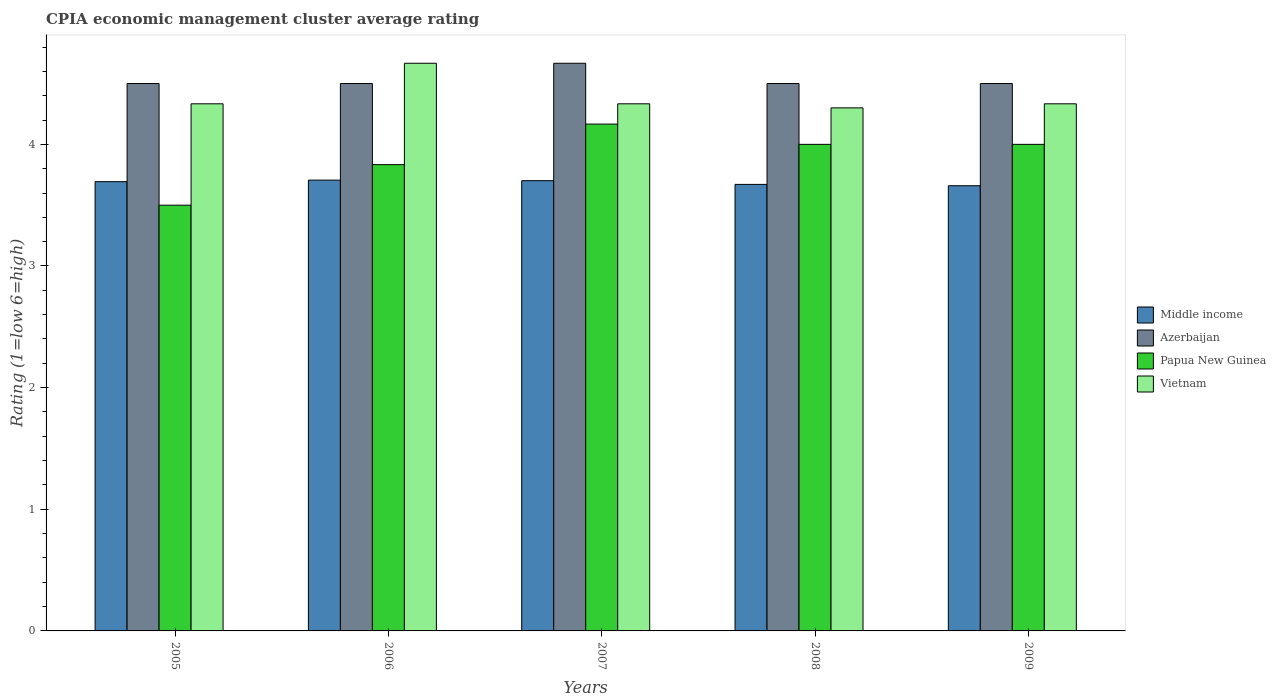Are the number of bars per tick equal to the number of legend labels?
Make the answer very short. Yes. How many bars are there on the 3rd tick from the left?
Make the answer very short. 4. What is the label of the 2nd group of bars from the left?
Your response must be concise. 2006. In how many cases, is the number of bars for a given year not equal to the number of legend labels?
Provide a succinct answer. 0. What is the CPIA rating in Middle income in 2008?
Your answer should be compact. 3.67. Across all years, what is the maximum CPIA rating in Azerbaijan?
Ensure brevity in your answer.  4.67. Across all years, what is the minimum CPIA rating in Middle income?
Keep it short and to the point. 3.66. In which year was the CPIA rating in Vietnam minimum?
Provide a succinct answer. 2008. What is the total CPIA rating in Vietnam in the graph?
Your answer should be compact. 21.97. What is the difference between the CPIA rating in Middle income in 2006 and that in 2008?
Provide a succinct answer. 0.04. What is the difference between the CPIA rating in Middle income in 2009 and the CPIA rating in Azerbaijan in 2006?
Provide a short and direct response. -0.84. In the year 2009, what is the difference between the CPIA rating in Middle income and CPIA rating in Papua New Guinea?
Your answer should be very brief. -0.34. In how many years, is the CPIA rating in Middle income greater than 3.6?
Provide a short and direct response. 5. What is the ratio of the CPIA rating in Azerbaijan in 2007 to that in 2008?
Your answer should be compact. 1.04. Is the CPIA rating in Middle income in 2007 less than that in 2009?
Provide a succinct answer. No. What is the difference between the highest and the second highest CPIA rating in Vietnam?
Your answer should be compact. 0.33. What is the difference between the highest and the lowest CPIA rating in Papua New Guinea?
Make the answer very short. 0.67. Is it the case that in every year, the sum of the CPIA rating in Papua New Guinea and CPIA rating in Azerbaijan is greater than the sum of CPIA rating in Vietnam and CPIA rating in Middle income?
Your answer should be compact. No. What does the 3rd bar from the left in 2009 represents?
Make the answer very short. Papua New Guinea. What does the 2nd bar from the right in 2007 represents?
Provide a short and direct response. Papua New Guinea. How many bars are there?
Provide a succinct answer. 20. Are all the bars in the graph horizontal?
Ensure brevity in your answer.  No. How many years are there in the graph?
Your response must be concise. 5. Does the graph contain grids?
Provide a short and direct response. No. Where does the legend appear in the graph?
Make the answer very short. Center right. What is the title of the graph?
Provide a succinct answer. CPIA economic management cluster average rating. What is the Rating (1=low 6=high) in Middle income in 2005?
Your response must be concise. 3.69. What is the Rating (1=low 6=high) in Azerbaijan in 2005?
Offer a terse response. 4.5. What is the Rating (1=low 6=high) of Papua New Guinea in 2005?
Provide a succinct answer. 3.5. What is the Rating (1=low 6=high) in Vietnam in 2005?
Ensure brevity in your answer.  4.33. What is the Rating (1=low 6=high) of Middle income in 2006?
Your response must be concise. 3.71. What is the Rating (1=low 6=high) in Azerbaijan in 2006?
Provide a short and direct response. 4.5. What is the Rating (1=low 6=high) of Papua New Guinea in 2006?
Provide a succinct answer. 3.83. What is the Rating (1=low 6=high) in Vietnam in 2006?
Your answer should be very brief. 4.67. What is the Rating (1=low 6=high) of Middle income in 2007?
Ensure brevity in your answer.  3.7. What is the Rating (1=low 6=high) in Azerbaijan in 2007?
Provide a short and direct response. 4.67. What is the Rating (1=low 6=high) in Papua New Guinea in 2007?
Your answer should be compact. 4.17. What is the Rating (1=low 6=high) of Vietnam in 2007?
Provide a short and direct response. 4.33. What is the Rating (1=low 6=high) of Middle income in 2008?
Your response must be concise. 3.67. What is the Rating (1=low 6=high) in Azerbaijan in 2008?
Offer a terse response. 4.5. What is the Rating (1=low 6=high) in Papua New Guinea in 2008?
Ensure brevity in your answer.  4. What is the Rating (1=low 6=high) in Vietnam in 2008?
Your answer should be compact. 4.3. What is the Rating (1=low 6=high) in Middle income in 2009?
Your answer should be very brief. 3.66. What is the Rating (1=low 6=high) in Vietnam in 2009?
Ensure brevity in your answer.  4.33. Across all years, what is the maximum Rating (1=low 6=high) in Middle income?
Give a very brief answer. 3.71. Across all years, what is the maximum Rating (1=low 6=high) of Azerbaijan?
Ensure brevity in your answer.  4.67. Across all years, what is the maximum Rating (1=low 6=high) in Papua New Guinea?
Provide a short and direct response. 4.17. Across all years, what is the maximum Rating (1=low 6=high) of Vietnam?
Keep it short and to the point. 4.67. Across all years, what is the minimum Rating (1=low 6=high) in Middle income?
Ensure brevity in your answer.  3.66. Across all years, what is the minimum Rating (1=low 6=high) of Azerbaijan?
Offer a terse response. 4.5. Across all years, what is the minimum Rating (1=low 6=high) in Vietnam?
Give a very brief answer. 4.3. What is the total Rating (1=low 6=high) in Middle income in the graph?
Keep it short and to the point. 18.43. What is the total Rating (1=low 6=high) of Azerbaijan in the graph?
Offer a terse response. 22.67. What is the total Rating (1=low 6=high) in Vietnam in the graph?
Offer a terse response. 21.97. What is the difference between the Rating (1=low 6=high) of Middle income in 2005 and that in 2006?
Offer a terse response. -0.01. What is the difference between the Rating (1=low 6=high) in Azerbaijan in 2005 and that in 2006?
Give a very brief answer. 0. What is the difference between the Rating (1=low 6=high) of Papua New Guinea in 2005 and that in 2006?
Your response must be concise. -0.33. What is the difference between the Rating (1=low 6=high) in Middle income in 2005 and that in 2007?
Provide a short and direct response. -0.01. What is the difference between the Rating (1=low 6=high) of Papua New Guinea in 2005 and that in 2007?
Keep it short and to the point. -0.67. What is the difference between the Rating (1=low 6=high) in Vietnam in 2005 and that in 2007?
Make the answer very short. 0. What is the difference between the Rating (1=low 6=high) in Middle income in 2005 and that in 2008?
Your response must be concise. 0.02. What is the difference between the Rating (1=low 6=high) of Azerbaijan in 2005 and that in 2008?
Give a very brief answer. 0. What is the difference between the Rating (1=low 6=high) in Papua New Guinea in 2005 and that in 2008?
Your response must be concise. -0.5. What is the difference between the Rating (1=low 6=high) of Middle income in 2005 and that in 2009?
Provide a succinct answer. 0.03. What is the difference between the Rating (1=low 6=high) of Azerbaijan in 2005 and that in 2009?
Keep it short and to the point. 0. What is the difference between the Rating (1=low 6=high) of Papua New Guinea in 2005 and that in 2009?
Ensure brevity in your answer.  -0.5. What is the difference between the Rating (1=low 6=high) of Vietnam in 2005 and that in 2009?
Provide a succinct answer. 0. What is the difference between the Rating (1=low 6=high) in Middle income in 2006 and that in 2007?
Offer a very short reply. 0. What is the difference between the Rating (1=low 6=high) of Azerbaijan in 2006 and that in 2007?
Ensure brevity in your answer.  -0.17. What is the difference between the Rating (1=low 6=high) in Papua New Guinea in 2006 and that in 2007?
Offer a terse response. -0.33. What is the difference between the Rating (1=low 6=high) in Vietnam in 2006 and that in 2007?
Make the answer very short. 0.33. What is the difference between the Rating (1=low 6=high) of Middle income in 2006 and that in 2008?
Offer a very short reply. 0.04. What is the difference between the Rating (1=low 6=high) of Azerbaijan in 2006 and that in 2008?
Provide a succinct answer. 0. What is the difference between the Rating (1=low 6=high) of Papua New Guinea in 2006 and that in 2008?
Ensure brevity in your answer.  -0.17. What is the difference between the Rating (1=low 6=high) in Vietnam in 2006 and that in 2008?
Offer a terse response. 0.37. What is the difference between the Rating (1=low 6=high) of Middle income in 2006 and that in 2009?
Make the answer very short. 0.05. What is the difference between the Rating (1=low 6=high) of Papua New Guinea in 2006 and that in 2009?
Your response must be concise. -0.17. What is the difference between the Rating (1=low 6=high) of Vietnam in 2006 and that in 2009?
Give a very brief answer. 0.33. What is the difference between the Rating (1=low 6=high) in Middle income in 2007 and that in 2008?
Your answer should be very brief. 0.03. What is the difference between the Rating (1=low 6=high) in Azerbaijan in 2007 and that in 2008?
Your answer should be compact. 0.17. What is the difference between the Rating (1=low 6=high) in Papua New Guinea in 2007 and that in 2008?
Ensure brevity in your answer.  0.17. What is the difference between the Rating (1=low 6=high) of Middle income in 2007 and that in 2009?
Provide a short and direct response. 0.04. What is the difference between the Rating (1=low 6=high) in Azerbaijan in 2007 and that in 2009?
Offer a terse response. 0.17. What is the difference between the Rating (1=low 6=high) in Middle income in 2008 and that in 2009?
Keep it short and to the point. 0.01. What is the difference between the Rating (1=low 6=high) of Azerbaijan in 2008 and that in 2009?
Keep it short and to the point. 0. What is the difference between the Rating (1=low 6=high) of Vietnam in 2008 and that in 2009?
Offer a very short reply. -0.03. What is the difference between the Rating (1=low 6=high) in Middle income in 2005 and the Rating (1=low 6=high) in Azerbaijan in 2006?
Provide a short and direct response. -0.81. What is the difference between the Rating (1=low 6=high) of Middle income in 2005 and the Rating (1=low 6=high) of Papua New Guinea in 2006?
Keep it short and to the point. -0.14. What is the difference between the Rating (1=low 6=high) of Middle income in 2005 and the Rating (1=low 6=high) of Vietnam in 2006?
Your response must be concise. -0.97. What is the difference between the Rating (1=low 6=high) of Papua New Guinea in 2005 and the Rating (1=low 6=high) of Vietnam in 2006?
Provide a short and direct response. -1.17. What is the difference between the Rating (1=low 6=high) in Middle income in 2005 and the Rating (1=low 6=high) in Azerbaijan in 2007?
Give a very brief answer. -0.97. What is the difference between the Rating (1=low 6=high) of Middle income in 2005 and the Rating (1=low 6=high) of Papua New Guinea in 2007?
Provide a short and direct response. -0.47. What is the difference between the Rating (1=low 6=high) of Middle income in 2005 and the Rating (1=low 6=high) of Vietnam in 2007?
Offer a terse response. -0.64. What is the difference between the Rating (1=low 6=high) in Azerbaijan in 2005 and the Rating (1=low 6=high) in Vietnam in 2007?
Offer a terse response. 0.17. What is the difference between the Rating (1=low 6=high) in Papua New Guinea in 2005 and the Rating (1=low 6=high) in Vietnam in 2007?
Give a very brief answer. -0.83. What is the difference between the Rating (1=low 6=high) of Middle income in 2005 and the Rating (1=low 6=high) of Azerbaijan in 2008?
Ensure brevity in your answer.  -0.81. What is the difference between the Rating (1=low 6=high) in Middle income in 2005 and the Rating (1=low 6=high) in Papua New Guinea in 2008?
Ensure brevity in your answer.  -0.31. What is the difference between the Rating (1=low 6=high) in Middle income in 2005 and the Rating (1=low 6=high) in Vietnam in 2008?
Your answer should be very brief. -0.61. What is the difference between the Rating (1=low 6=high) in Azerbaijan in 2005 and the Rating (1=low 6=high) in Vietnam in 2008?
Keep it short and to the point. 0.2. What is the difference between the Rating (1=low 6=high) of Papua New Guinea in 2005 and the Rating (1=low 6=high) of Vietnam in 2008?
Your answer should be compact. -0.8. What is the difference between the Rating (1=low 6=high) of Middle income in 2005 and the Rating (1=low 6=high) of Azerbaijan in 2009?
Keep it short and to the point. -0.81. What is the difference between the Rating (1=low 6=high) of Middle income in 2005 and the Rating (1=low 6=high) of Papua New Guinea in 2009?
Your answer should be compact. -0.31. What is the difference between the Rating (1=low 6=high) of Middle income in 2005 and the Rating (1=low 6=high) of Vietnam in 2009?
Your response must be concise. -0.64. What is the difference between the Rating (1=low 6=high) in Azerbaijan in 2005 and the Rating (1=low 6=high) in Papua New Guinea in 2009?
Provide a short and direct response. 0.5. What is the difference between the Rating (1=low 6=high) of Azerbaijan in 2005 and the Rating (1=low 6=high) of Vietnam in 2009?
Provide a short and direct response. 0.17. What is the difference between the Rating (1=low 6=high) in Papua New Guinea in 2005 and the Rating (1=low 6=high) in Vietnam in 2009?
Provide a succinct answer. -0.83. What is the difference between the Rating (1=low 6=high) of Middle income in 2006 and the Rating (1=low 6=high) of Azerbaijan in 2007?
Offer a very short reply. -0.96. What is the difference between the Rating (1=low 6=high) in Middle income in 2006 and the Rating (1=low 6=high) in Papua New Guinea in 2007?
Keep it short and to the point. -0.46. What is the difference between the Rating (1=low 6=high) of Middle income in 2006 and the Rating (1=low 6=high) of Vietnam in 2007?
Offer a very short reply. -0.63. What is the difference between the Rating (1=low 6=high) of Azerbaijan in 2006 and the Rating (1=low 6=high) of Papua New Guinea in 2007?
Your answer should be compact. 0.33. What is the difference between the Rating (1=low 6=high) in Papua New Guinea in 2006 and the Rating (1=low 6=high) in Vietnam in 2007?
Ensure brevity in your answer.  -0.5. What is the difference between the Rating (1=low 6=high) in Middle income in 2006 and the Rating (1=low 6=high) in Azerbaijan in 2008?
Provide a succinct answer. -0.79. What is the difference between the Rating (1=low 6=high) of Middle income in 2006 and the Rating (1=low 6=high) of Papua New Guinea in 2008?
Keep it short and to the point. -0.29. What is the difference between the Rating (1=low 6=high) in Middle income in 2006 and the Rating (1=low 6=high) in Vietnam in 2008?
Provide a short and direct response. -0.59. What is the difference between the Rating (1=low 6=high) in Azerbaijan in 2006 and the Rating (1=low 6=high) in Vietnam in 2008?
Your answer should be very brief. 0.2. What is the difference between the Rating (1=low 6=high) of Papua New Guinea in 2006 and the Rating (1=low 6=high) of Vietnam in 2008?
Make the answer very short. -0.47. What is the difference between the Rating (1=low 6=high) of Middle income in 2006 and the Rating (1=low 6=high) of Azerbaijan in 2009?
Your response must be concise. -0.79. What is the difference between the Rating (1=low 6=high) of Middle income in 2006 and the Rating (1=low 6=high) of Papua New Guinea in 2009?
Make the answer very short. -0.29. What is the difference between the Rating (1=low 6=high) in Middle income in 2006 and the Rating (1=low 6=high) in Vietnam in 2009?
Your answer should be compact. -0.63. What is the difference between the Rating (1=low 6=high) of Azerbaijan in 2006 and the Rating (1=low 6=high) of Papua New Guinea in 2009?
Your response must be concise. 0.5. What is the difference between the Rating (1=low 6=high) in Middle income in 2007 and the Rating (1=low 6=high) in Azerbaijan in 2008?
Provide a short and direct response. -0.8. What is the difference between the Rating (1=low 6=high) in Middle income in 2007 and the Rating (1=low 6=high) in Papua New Guinea in 2008?
Your response must be concise. -0.3. What is the difference between the Rating (1=low 6=high) in Middle income in 2007 and the Rating (1=low 6=high) in Vietnam in 2008?
Offer a terse response. -0.6. What is the difference between the Rating (1=low 6=high) of Azerbaijan in 2007 and the Rating (1=low 6=high) of Vietnam in 2008?
Provide a succinct answer. 0.37. What is the difference between the Rating (1=low 6=high) in Papua New Guinea in 2007 and the Rating (1=low 6=high) in Vietnam in 2008?
Your answer should be very brief. -0.13. What is the difference between the Rating (1=low 6=high) in Middle income in 2007 and the Rating (1=low 6=high) in Azerbaijan in 2009?
Keep it short and to the point. -0.8. What is the difference between the Rating (1=low 6=high) in Middle income in 2007 and the Rating (1=low 6=high) in Papua New Guinea in 2009?
Offer a terse response. -0.3. What is the difference between the Rating (1=low 6=high) in Middle income in 2007 and the Rating (1=low 6=high) in Vietnam in 2009?
Provide a short and direct response. -0.63. What is the difference between the Rating (1=low 6=high) of Middle income in 2008 and the Rating (1=low 6=high) of Azerbaijan in 2009?
Provide a short and direct response. -0.83. What is the difference between the Rating (1=low 6=high) of Middle income in 2008 and the Rating (1=low 6=high) of Papua New Guinea in 2009?
Give a very brief answer. -0.33. What is the difference between the Rating (1=low 6=high) in Middle income in 2008 and the Rating (1=low 6=high) in Vietnam in 2009?
Make the answer very short. -0.66. What is the difference between the Rating (1=low 6=high) of Azerbaijan in 2008 and the Rating (1=low 6=high) of Vietnam in 2009?
Ensure brevity in your answer.  0.17. What is the average Rating (1=low 6=high) in Middle income per year?
Keep it short and to the point. 3.69. What is the average Rating (1=low 6=high) in Azerbaijan per year?
Offer a very short reply. 4.53. What is the average Rating (1=low 6=high) of Vietnam per year?
Offer a terse response. 4.39. In the year 2005, what is the difference between the Rating (1=low 6=high) of Middle income and Rating (1=low 6=high) of Azerbaijan?
Offer a terse response. -0.81. In the year 2005, what is the difference between the Rating (1=low 6=high) of Middle income and Rating (1=low 6=high) of Papua New Guinea?
Provide a succinct answer. 0.19. In the year 2005, what is the difference between the Rating (1=low 6=high) of Middle income and Rating (1=low 6=high) of Vietnam?
Give a very brief answer. -0.64. In the year 2005, what is the difference between the Rating (1=low 6=high) of Azerbaijan and Rating (1=low 6=high) of Vietnam?
Keep it short and to the point. 0.17. In the year 2005, what is the difference between the Rating (1=low 6=high) of Papua New Guinea and Rating (1=low 6=high) of Vietnam?
Give a very brief answer. -0.83. In the year 2006, what is the difference between the Rating (1=low 6=high) in Middle income and Rating (1=low 6=high) in Azerbaijan?
Give a very brief answer. -0.79. In the year 2006, what is the difference between the Rating (1=low 6=high) of Middle income and Rating (1=low 6=high) of Papua New Guinea?
Give a very brief answer. -0.13. In the year 2006, what is the difference between the Rating (1=low 6=high) of Middle income and Rating (1=low 6=high) of Vietnam?
Make the answer very short. -0.96. In the year 2006, what is the difference between the Rating (1=low 6=high) of Azerbaijan and Rating (1=low 6=high) of Papua New Guinea?
Your answer should be compact. 0.67. In the year 2006, what is the difference between the Rating (1=low 6=high) of Azerbaijan and Rating (1=low 6=high) of Vietnam?
Provide a short and direct response. -0.17. In the year 2006, what is the difference between the Rating (1=low 6=high) of Papua New Guinea and Rating (1=low 6=high) of Vietnam?
Keep it short and to the point. -0.83. In the year 2007, what is the difference between the Rating (1=low 6=high) in Middle income and Rating (1=low 6=high) in Azerbaijan?
Provide a succinct answer. -0.97. In the year 2007, what is the difference between the Rating (1=low 6=high) of Middle income and Rating (1=low 6=high) of Papua New Guinea?
Your answer should be very brief. -0.47. In the year 2007, what is the difference between the Rating (1=low 6=high) of Middle income and Rating (1=low 6=high) of Vietnam?
Make the answer very short. -0.63. In the year 2007, what is the difference between the Rating (1=low 6=high) of Azerbaijan and Rating (1=low 6=high) of Papua New Guinea?
Give a very brief answer. 0.5. In the year 2008, what is the difference between the Rating (1=low 6=high) of Middle income and Rating (1=low 6=high) of Azerbaijan?
Offer a terse response. -0.83. In the year 2008, what is the difference between the Rating (1=low 6=high) of Middle income and Rating (1=low 6=high) of Papua New Guinea?
Offer a terse response. -0.33. In the year 2008, what is the difference between the Rating (1=low 6=high) of Middle income and Rating (1=low 6=high) of Vietnam?
Your answer should be very brief. -0.63. In the year 2008, what is the difference between the Rating (1=low 6=high) of Azerbaijan and Rating (1=low 6=high) of Vietnam?
Your answer should be very brief. 0.2. In the year 2009, what is the difference between the Rating (1=low 6=high) of Middle income and Rating (1=low 6=high) of Azerbaijan?
Keep it short and to the point. -0.84. In the year 2009, what is the difference between the Rating (1=low 6=high) in Middle income and Rating (1=low 6=high) in Papua New Guinea?
Your answer should be very brief. -0.34. In the year 2009, what is the difference between the Rating (1=low 6=high) in Middle income and Rating (1=low 6=high) in Vietnam?
Your response must be concise. -0.67. In the year 2009, what is the difference between the Rating (1=low 6=high) of Papua New Guinea and Rating (1=low 6=high) of Vietnam?
Make the answer very short. -0.33. What is the ratio of the Rating (1=low 6=high) in Azerbaijan in 2005 to that in 2006?
Your answer should be compact. 1. What is the ratio of the Rating (1=low 6=high) of Papua New Guinea in 2005 to that in 2006?
Offer a terse response. 0.91. What is the ratio of the Rating (1=low 6=high) in Azerbaijan in 2005 to that in 2007?
Offer a terse response. 0.96. What is the ratio of the Rating (1=low 6=high) in Papua New Guinea in 2005 to that in 2007?
Offer a very short reply. 0.84. What is the ratio of the Rating (1=low 6=high) in Vietnam in 2005 to that in 2007?
Offer a very short reply. 1. What is the ratio of the Rating (1=low 6=high) of Middle income in 2005 to that in 2008?
Ensure brevity in your answer.  1.01. What is the ratio of the Rating (1=low 6=high) of Middle income in 2005 to that in 2009?
Provide a succinct answer. 1.01. What is the ratio of the Rating (1=low 6=high) of Papua New Guinea in 2005 to that in 2009?
Your answer should be very brief. 0.88. What is the ratio of the Rating (1=low 6=high) in Vietnam in 2005 to that in 2009?
Offer a very short reply. 1. What is the ratio of the Rating (1=low 6=high) of Azerbaijan in 2006 to that in 2007?
Your answer should be very brief. 0.96. What is the ratio of the Rating (1=low 6=high) in Papua New Guinea in 2006 to that in 2007?
Make the answer very short. 0.92. What is the ratio of the Rating (1=low 6=high) in Middle income in 2006 to that in 2008?
Provide a short and direct response. 1.01. What is the ratio of the Rating (1=low 6=high) of Azerbaijan in 2006 to that in 2008?
Provide a succinct answer. 1. What is the ratio of the Rating (1=low 6=high) of Papua New Guinea in 2006 to that in 2008?
Give a very brief answer. 0.96. What is the ratio of the Rating (1=low 6=high) of Vietnam in 2006 to that in 2008?
Give a very brief answer. 1.09. What is the ratio of the Rating (1=low 6=high) of Middle income in 2006 to that in 2009?
Make the answer very short. 1.01. What is the ratio of the Rating (1=low 6=high) in Papua New Guinea in 2006 to that in 2009?
Your answer should be compact. 0.96. What is the ratio of the Rating (1=low 6=high) in Middle income in 2007 to that in 2008?
Your answer should be compact. 1.01. What is the ratio of the Rating (1=low 6=high) in Papua New Guinea in 2007 to that in 2008?
Your answer should be very brief. 1.04. What is the ratio of the Rating (1=low 6=high) of Vietnam in 2007 to that in 2008?
Your answer should be very brief. 1.01. What is the ratio of the Rating (1=low 6=high) in Middle income in 2007 to that in 2009?
Keep it short and to the point. 1.01. What is the ratio of the Rating (1=low 6=high) in Azerbaijan in 2007 to that in 2009?
Your answer should be compact. 1.04. What is the ratio of the Rating (1=low 6=high) of Papua New Guinea in 2007 to that in 2009?
Ensure brevity in your answer.  1.04. What is the ratio of the Rating (1=low 6=high) of Vietnam in 2008 to that in 2009?
Offer a terse response. 0.99. What is the difference between the highest and the second highest Rating (1=low 6=high) in Middle income?
Keep it short and to the point. 0. What is the difference between the highest and the second highest Rating (1=low 6=high) of Azerbaijan?
Provide a short and direct response. 0.17. What is the difference between the highest and the second highest Rating (1=low 6=high) in Papua New Guinea?
Give a very brief answer. 0.17. What is the difference between the highest and the lowest Rating (1=low 6=high) of Middle income?
Your answer should be compact. 0.05. What is the difference between the highest and the lowest Rating (1=low 6=high) of Azerbaijan?
Make the answer very short. 0.17. What is the difference between the highest and the lowest Rating (1=low 6=high) of Vietnam?
Give a very brief answer. 0.37. 